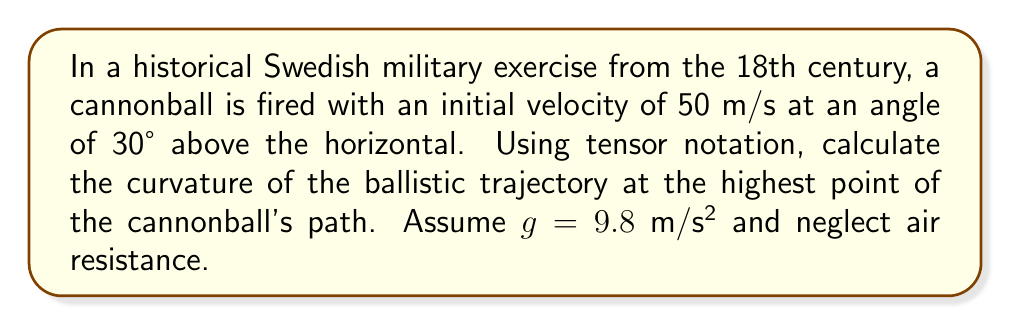Solve this math problem. To solve this problem, we'll follow these steps:

1) First, let's define the position vector $\mathbf{r}(t)$ of the cannonball:

   $$\mathbf{r}(t) = \begin{pmatrix} x(t) \\ y(t) \end{pmatrix} = \begin{pmatrix} v_0 \cos{\theta} \cdot t \\ v_0 \sin{\theta} \cdot t - \frac{1}{2}gt^2 \end{pmatrix}$$

   where $v_0 = 50$ m/s, $\theta = 30°$, and $g = 9.8$ m/s².

2) The velocity vector $\mathbf{v}(t)$ is the first derivative of $\mathbf{r}(t)$:

   $$\mathbf{v}(t) = \frac{d\mathbf{r}}{dt} = \begin{pmatrix} v_0 \cos{\theta} \\ v_0 \sin{\theta} - gt \end{pmatrix}$$

3) The acceleration vector $\mathbf{a}(t)$ is the second derivative of $\mathbf{r}(t)$:

   $$\mathbf{a}(t) = \frac{d^2\mathbf{r}}{dt^2} = \begin{pmatrix} 0 \\ -g \end{pmatrix}$$

4) The curvature $\kappa$ is given by:

   $$\kappa = \frac{|\mathbf{v} \times \mathbf{a}|}{|\mathbf{v}|^3}$$

5) At the highest point, the vertical component of velocity is zero. We can find the time $t_h$ when this occurs:

   $$v_0 \sin{\theta} - gt_h = 0$$
   $$t_h = \frac{v_0 \sin{\theta}}{g} = \frac{50 \sin{30°}}{9.8} \approx 2.55 \text{ s}$$

6) Now we can calculate $\mathbf{v}$ and $|\mathbf{v}|$ at this point:

   $$\mathbf{v}(t_h) = \begin{pmatrix} v_0 \cos{\theta} \\ 0 \end{pmatrix} = \begin{pmatrix} 50 \cos{30°} \\ 0 \end{pmatrix} \approx \begin{pmatrix} 43.3 \\ 0 \end{pmatrix}$$

   $$|\mathbf{v}(t_h)| = 43.3 \text{ m/s}$$

7) The acceleration $\mathbf{a}$ is constant:

   $$\mathbf{a} = \begin{pmatrix} 0 \\ -9.8 \end{pmatrix}$$

8) Now we can calculate the cross product $\mathbf{v} \times \mathbf{a}$:

   $$|\mathbf{v} \times \mathbf{a}| = |v_x a_y - v_y a_x| = |43.3 \cdot (-9.8) - 0 \cdot 0| = 424.34$$

9) Finally, we can calculate the curvature:

   $$\kappa = \frac{|\mathbf{v} \times \mathbf{a}|}{|\mathbf{v}|^3} = \frac{424.34}{43.3^3} \approx 0.0052 \text{ m}^{-1}$$
Answer: $\kappa \approx 0.0052 \text{ m}^{-1}$ 